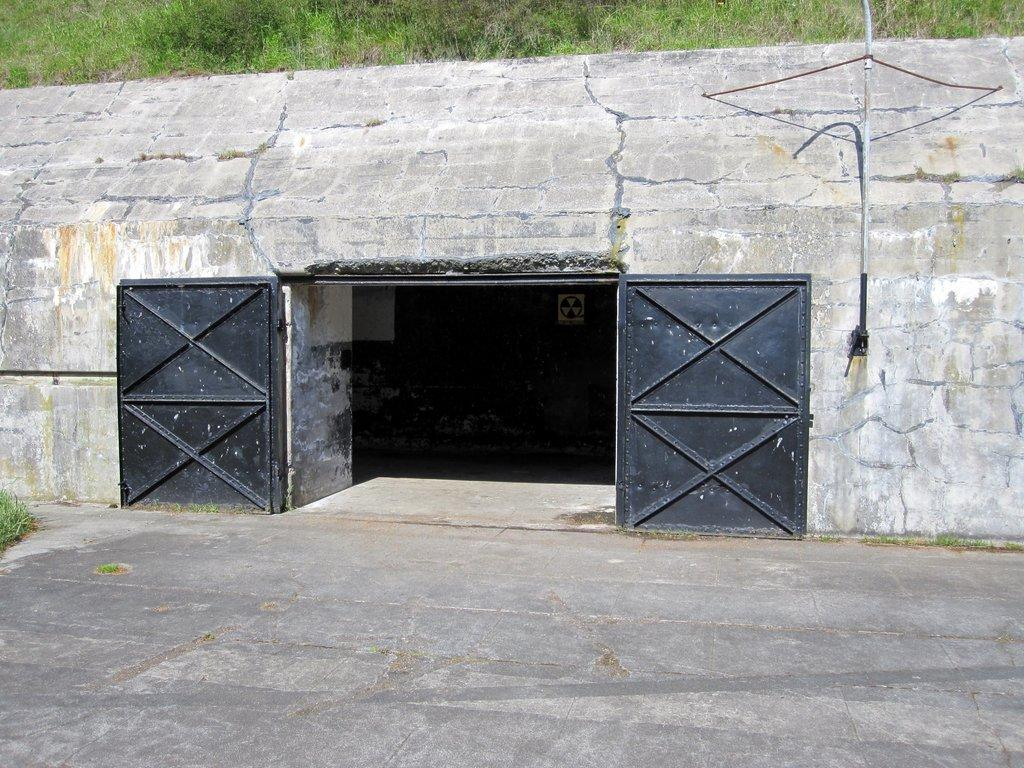What color are the doors in the image? The doors in the image are black. What can be seen behind the doors in the image? There is a wall visible in the image. What type of vegetation is present in the image? There is grass in the image. What is the surface at the bottom of the image? There is a path at the bottom of the image. What type of silk fabric is draped over the window in the image? There is no window or silk fabric present in the image. How many planes can be seen flying in the sky in the image? There are no planes visible in the image. 